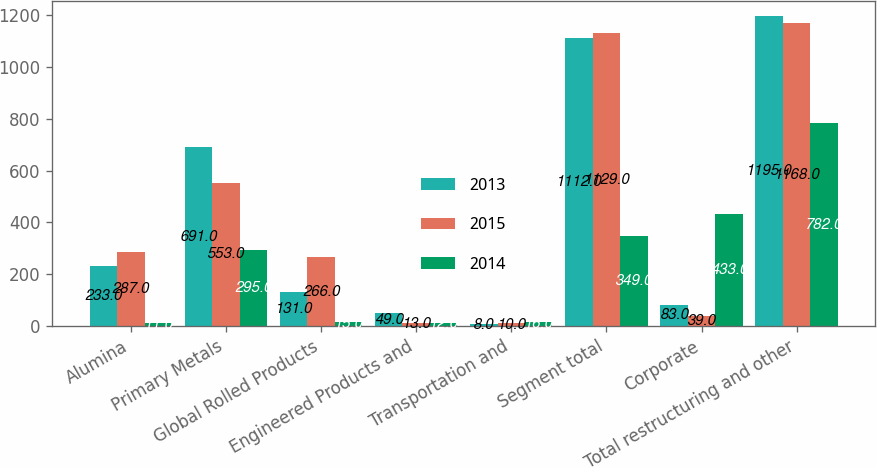Convert chart. <chart><loc_0><loc_0><loc_500><loc_500><stacked_bar_chart><ecel><fcel>Alumina<fcel>Primary Metals<fcel>Global Rolled Products<fcel>Engineered Products and<fcel>Transportation and<fcel>Segment total<fcel>Corporate<fcel>Total restructuring and other<nl><fcel>2013<fcel>233<fcel>691<fcel>131<fcel>49<fcel>8<fcel>1112<fcel>83<fcel>1195<nl><fcel>2015<fcel>287<fcel>553<fcel>266<fcel>13<fcel>10<fcel>1129<fcel>39<fcel>1168<nl><fcel>2014<fcel>11<fcel>295<fcel>15<fcel>12<fcel>16<fcel>349<fcel>433<fcel>782<nl></chart> 